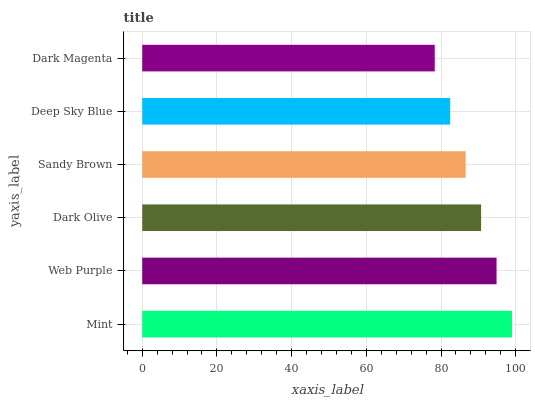Is Dark Magenta the minimum?
Answer yes or no. Yes. Is Mint the maximum?
Answer yes or no. Yes. Is Web Purple the minimum?
Answer yes or no. No. Is Web Purple the maximum?
Answer yes or no. No. Is Mint greater than Web Purple?
Answer yes or no. Yes. Is Web Purple less than Mint?
Answer yes or no. Yes. Is Web Purple greater than Mint?
Answer yes or no. No. Is Mint less than Web Purple?
Answer yes or no. No. Is Dark Olive the high median?
Answer yes or no. Yes. Is Sandy Brown the low median?
Answer yes or no. Yes. Is Web Purple the high median?
Answer yes or no. No. Is Mint the low median?
Answer yes or no. No. 